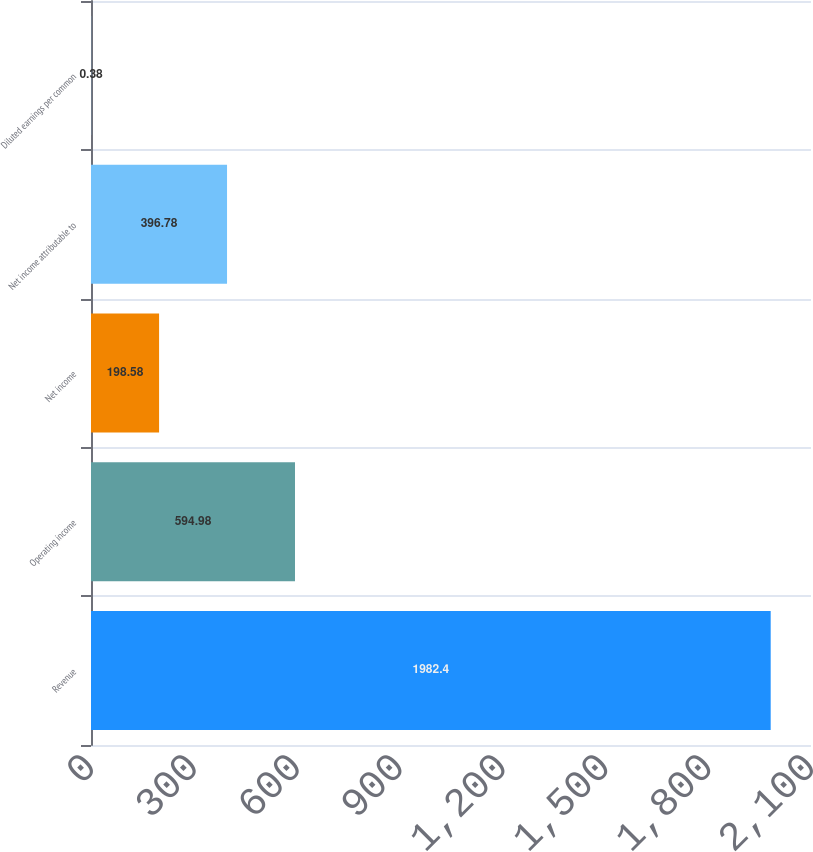<chart> <loc_0><loc_0><loc_500><loc_500><bar_chart><fcel>Revenue<fcel>Operating income<fcel>Net income<fcel>Net income attributable to<fcel>Diluted earnings per common<nl><fcel>1982.4<fcel>594.98<fcel>198.58<fcel>396.78<fcel>0.38<nl></chart> 